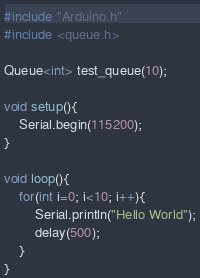Convert code to text. <code><loc_0><loc_0><loc_500><loc_500><_C++_>#include "Arduino.h"
#include <queue.h>

Queue<int> test_queue(10);

void setup(){
    Serial.begin(115200);
}

void loop(){
    for(int i=0; i<10; i++){
        Serial.println("Hello World");
        delay(500);
    }
}
</code> 